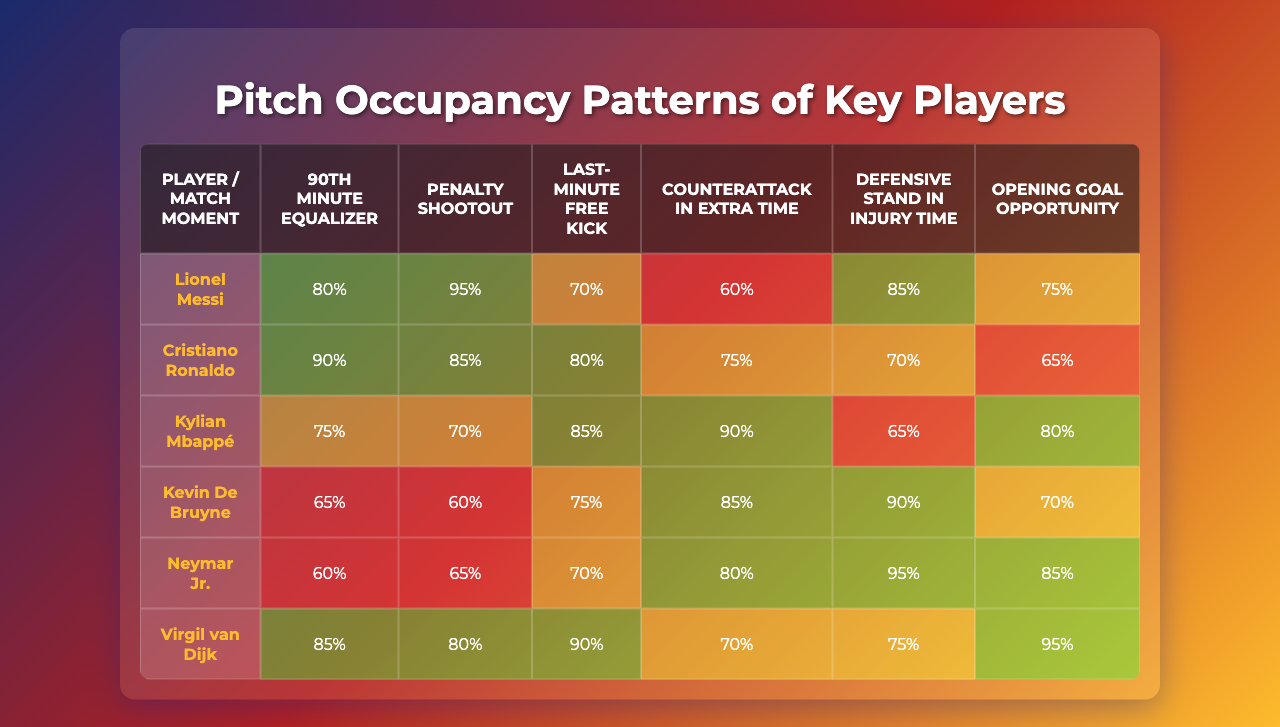What player had the highest occupancy during the penalty shootout? By looking at the row for the penalty shootout, we see that Kylian Mbappé had the highest occupancy at 90%.
Answer: Kylian Mbappé What is the occupancy percentage for Virgil van Dijk during the last-minute free kick? Referring to the table, Virgil van Dijk's occupancy during the last-minute free kick is 90%.
Answer: 90% Which player had the lowest occupancy in the defensive third during the opening goal opportunity? In the defensive third column corresponding to the opening goal opportunity, Kylian Mbappé had the lowest occupancy with 65%.
Answer: Kylian Mbappé What is the average occupancy across all players during the 90th minute equalizer? To find the average, sum the occupancy values for all players in that moment: 80 + 90 + 75 + 65 + 60 + 85 = 455, and divide by 6 (the number of players): 455 / 6 = 75.83, so the average occupancy is approximately 76%.
Answer: 76% Did Kevin De Bruyne exceed 80% occupancy in any match moment? By checking Kevin De Bruyne's occupancy percentages in all moments, we find that he did exceed 80% during the last-minute free kick (85%) and the defensive stand in injury time (90%).
Answer: Yes Which player showed the most consistent presence across all match moments? By examining the occupancy data, we see that while both Neymar Jr. and Virgil van Dijk have high numbers, Virgil van Dijk maintained a greater percentage across crucial moments compared to the others, specifically being in high occupancy categories in various pivotal moments.
Answer: Virgil van Dijk How many players had occupancy percentages below 70% during the penalty shootout? Observing the penalty shootout row, only one player, Virgil van Dijk, had an occupancy below 70%, with a value of 65%.
Answer: 1 What was the overall trend in occupancy for Lionel Messi during the match moments? Analyzing Messi’s occupancy data (80, 90, 75, 65, 60, 85), we observe a general decline from the 90th minute equalizer through the defensive stand, before recovering during the opening goal opportunity. This indicates fluctuating but ultimately strong engagement throughout the match.
Answer: Inconsistent trend Which match moment had the overall highest occupancy value when combined across all players? Adding the occupancies for each player during each match moment, we find that the penalty shootout has the highest combined occupancy: 90 + 85 + 80 + 75 + 70 + 65 = 465, indicating that it is the most pivotal moment in terms of player engagement.
Answer: Penalty shootout How does Neymar Jr.’s occupancy in the left wing compare to his occupancy in the attacking third during the opening goal opportunity? Neymar Jr.'s occupancy in the left wing during the opening goal opportunity is 70%, and in the attacking third it is 80%. Therefore, his occupancy in the attacking third is higher than in the left wing by 10%.
Answer: Attacking third is higher by 10% 